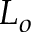Convert formula to latex. <formula><loc_0><loc_0><loc_500><loc_500>L _ { o }</formula> 